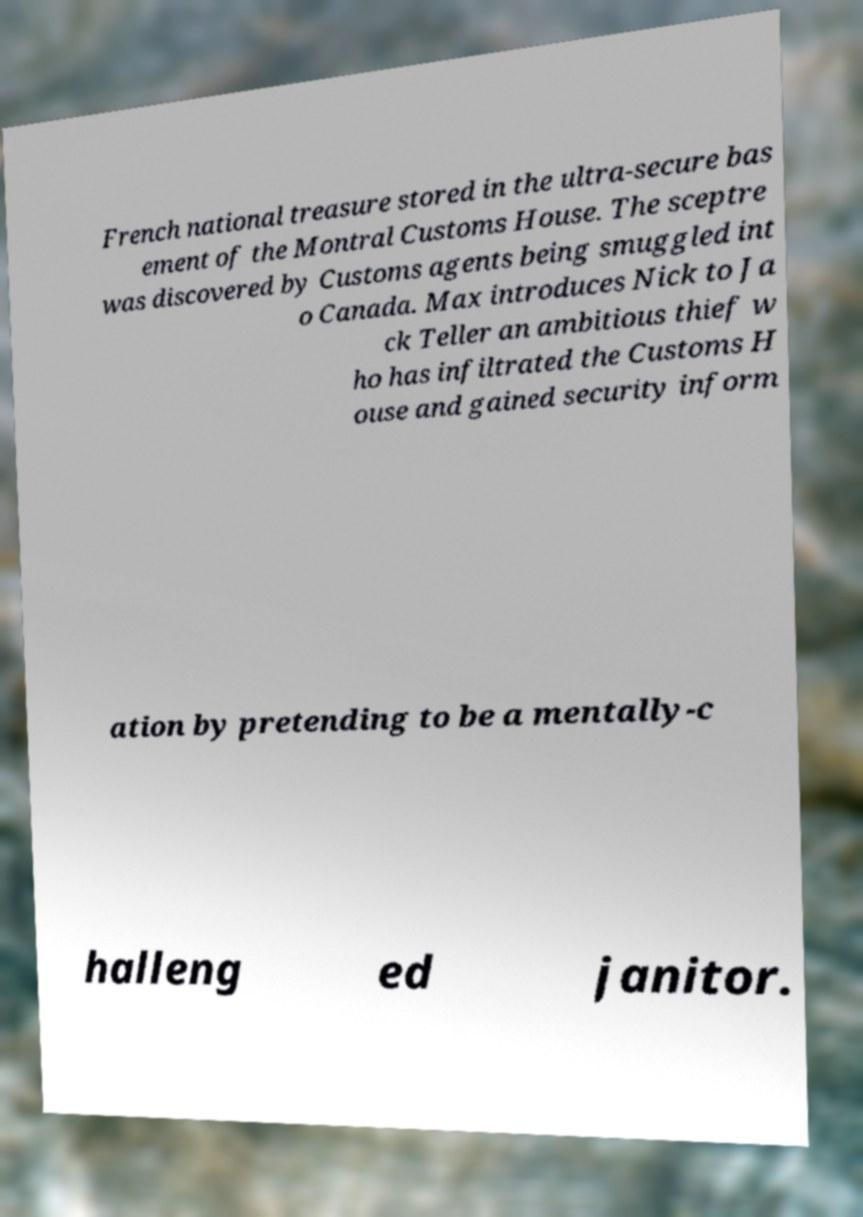I need the written content from this picture converted into text. Can you do that? French national treasure stored in the ultra-secure bas ement of the Montral Customs House. The sceptre was discovered by Customs agents being smuggled int o Canada. Max introduces Nick to Ja ck Teller an ambitious thief w ho has infiltrated the Customs H ouse and gained security inform ation by pretending to be a mentally-c halleng ed janitor. 